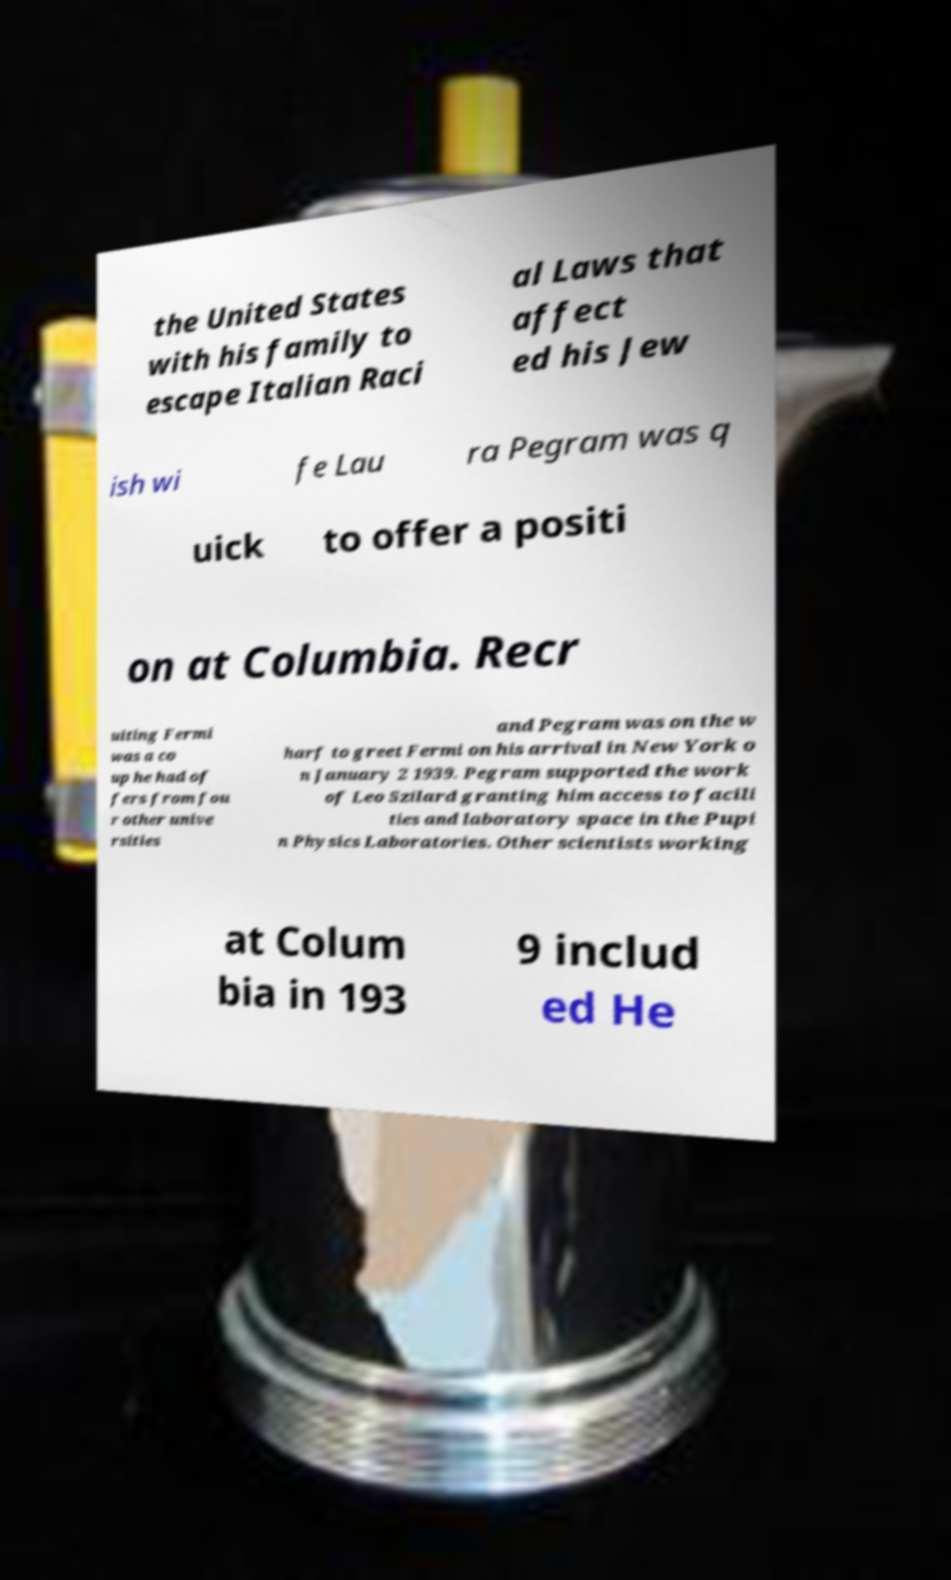For documentation purposes, I need the text within this image transcribed. Could you provide that? the United States with his family to escape Italian Raci al Laws that affect ed his Jew ish wi fe Lau ra Pegram was q uick to offer a positi on at Columbia. Recr uiting Fermi was a co up he had of fers from fou r other unive rsities and Pegram was on the w harf to greet Fermi on his arrival in New York o n January 2 1939. Pegram supported the work of Leo Szilard granting him access to facili ties and laboratory space in the Pupi n Physics Laboratories. Other scientists working at Colum bia in 193 9 includ ed He 